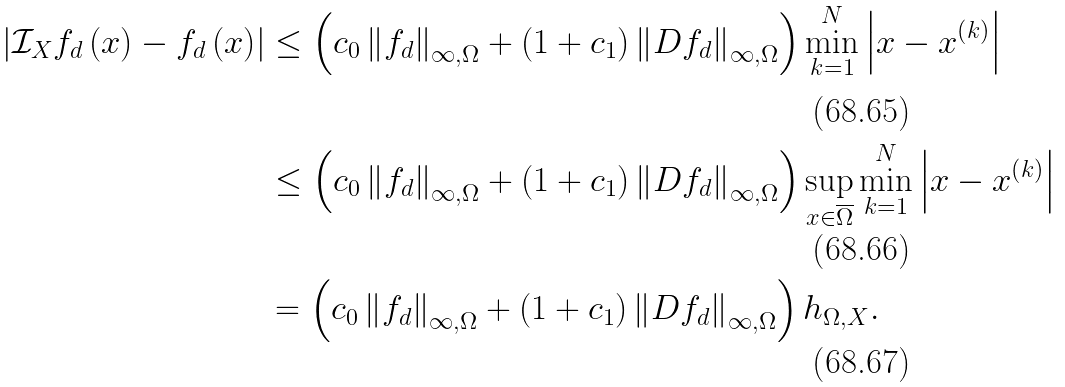Convert formula to latex. <formula><loc_0><loc_0><loc_500><loc_500>\left | \mathcal { I } _ { X } f _ { d } \left ( x \right ) - f _ { d } \left ( x \right ) \right | & \leq \left ( c _ { 0 } \left \| f _ { d } \right \| _ { \infty , \Omega } + \left ( 1 + c _ { 1 } \right ) \left \| D f _ { d } \right \| _ { \infty , \Omega } \right ) \min _ { k = 1 } ^ { N } \left | x - x ^ { \left ( k \right ) } \right | \\ & \leq \left ( c _ { 0 } \left \| f _ { d } \right \| _ { \infty , \Omega } + \left ( 1 + c _ { 1 } \right ) \left \| D f _ { d } \right \| _ { \infty , \Omega } \right ) \sup _ { x \in \overline { \Omega } } \min _ { k = 1 } ^ { N } \left | x - x ^ { \left ( k \right ) } \right | \\ & = \left ( c _ { 0 } \left \| f _ { d } \right \| _ { \infty , \Omega } + \left ( 1 + c _ { 1 } \right ) \left \| D f _ { d } \right \| _ { \infty , \Omega } \right ) h _ { \Omega , X } .</formula> 